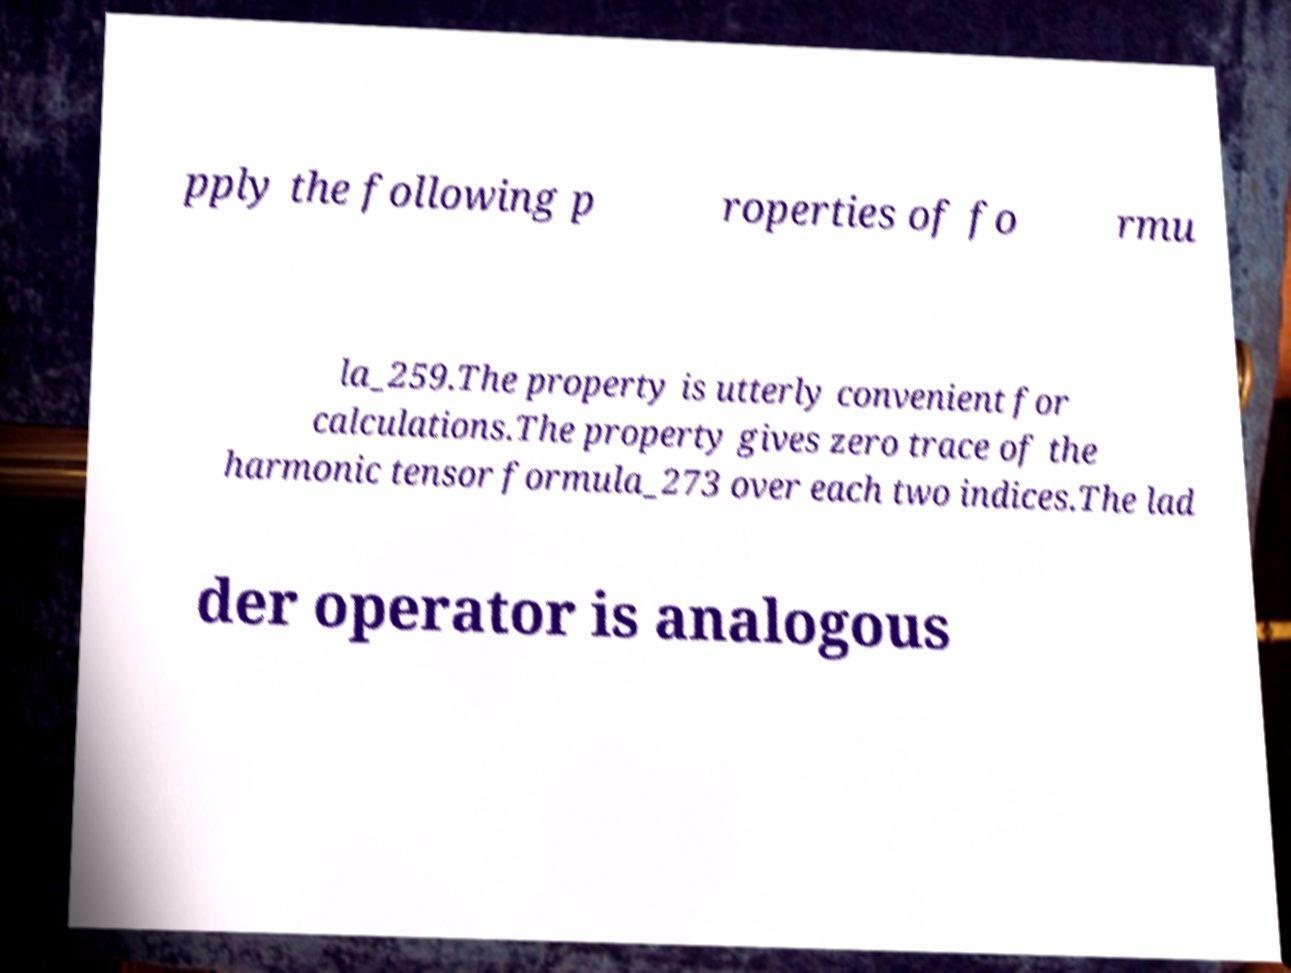Could you assist in decoding the text presented in this image and type it out clearly? pply the following p roperties of fo rmu la_259.The property is utterly convenient for calculations.The property gives zero trace of the harmonic tensor formula_273 over each two indices.The lad der operator is analogous 